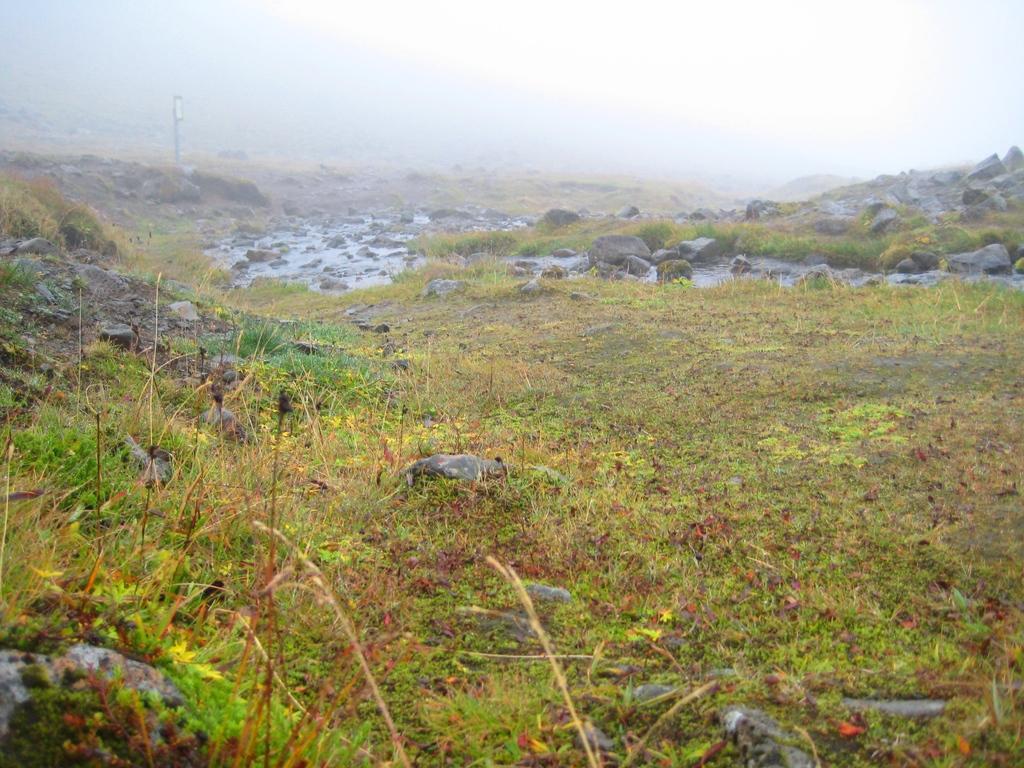Describe this image in one or two sentences. In this image we can see some rocks, plants, grass and water. In the background, we can see the sky. 